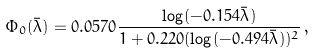Convert formula to latex. <formula><loc_0><loc_0><loc_500><loc_500>\Phi _ { 0 } ( \bar { \lambda } ) = 0 . 0 5 7 0 \frac { \log ( - 0 . 1 5 4 \bar { \lambda } ) } { 1 + 0 . 2 2 0 ( \log ( - 0 . 4 9 4 \bar { \lambda } ) ) ^ { 2 } } \, , \\</formula> 